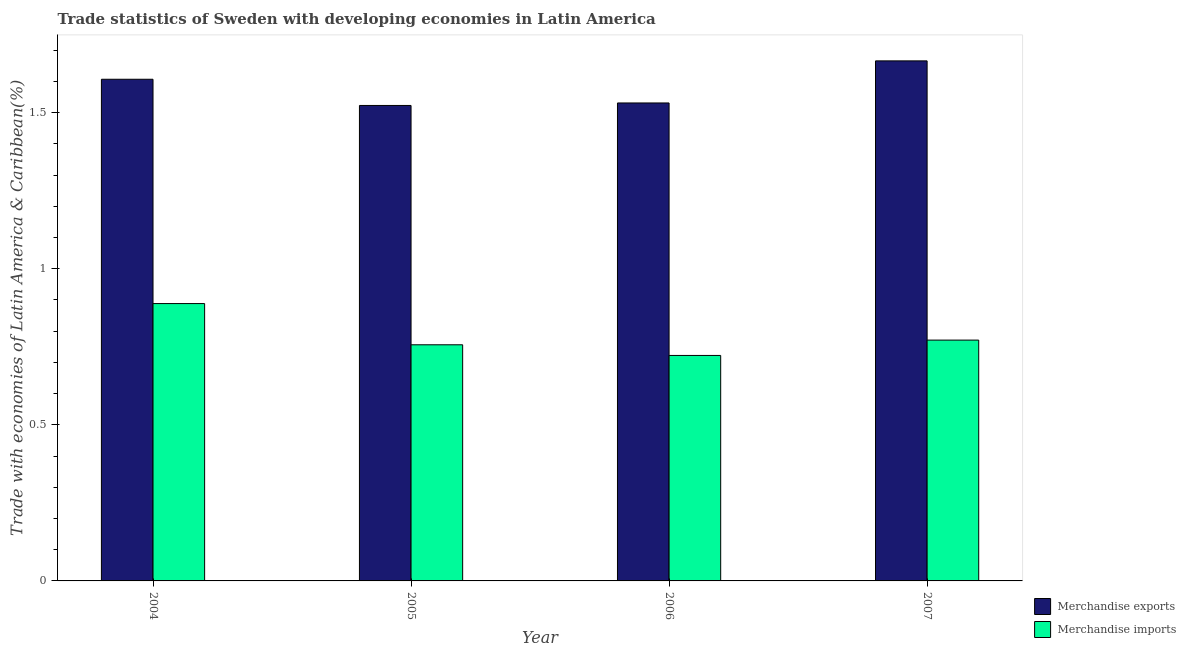How many different coloured bars are there?
Provide a succinct answer. 2. Are the number of bars per tick equal to the number of legend labels?
Make the answer very short. Yes. What is the label of the 2nd group of bars from the left?
Give a very brief answer. 2005. What is the merchandise imports in 2007?
Offer a terse response. 0.77. Across all years, what is the maximum merchandise imports?
Provide a short and direct response. 0.89. Across all years, what is the minimum merchandise exports?
Provide a short and direct response. 1.52. In which year was the merchandise imports maximum?
Give a very brief answer. 2004. What is the total merchandise exports in the graph?
Provide a short and direct response. 6.33. What is the difference between the merchandise imports in 2004 and that in 2006?
Give a very brief answer. 0.17. What is the difference between the merchandise imports in 2005 and the merchandise exports in 2007?
Make the answer very short. -0.02. What is the average merchandise imports per year?
Provide a succinct answer. 0.78. What is the ratio of the merchandise imports in 2006 to that in 2007?
Make the answer very short. 0.94. Is the merchandise imports in 2004 less than that in 2007?
Your answer should be very brief. No. Is the difference between the merchandise imports in 2005 and 2006 greater than the difference between the merchandise exports in 2005 and 2006?
Keep it short and to the point. No. What is the difference between the highest and the second highest merchandise exports?
Keep it short and to the point. 0.06. What is the difference between the highest and the lowest merchandise imports?
Provide a short and direct response. 0.17. Is the sum of the merchandise exports in 2005 and 2006 greater than the maximum merchandise imports across all years?
Your answer should be very brief. Yes. What does the 1st bar from the left in 2004 represents?
Provide a short and direct response. Merchandise exports. What does the 2nd bar from the right in 2007 represents?
Offer a terse response. Merchandise exports. How many bars are there?
Keep it short and to the point. 8. Are all the bars in the graph horizontal?
Make the answer very short. No. How many years are there in the graph?
Your answer should be very brief. 4. What is the title of the graph?
Offer a very short reply. Trade statistics of Sweden with developing economies in Latin America. What is the label or title of the Y-axis?
Your answer should be compact. Trade with economies of Latin America & Caribbean(%). What is the Trade with economies of Latin America & Caribbean(%) in Merchandise exports in 2004?
Offer a very short reply. 1.61. What is the Trade with economies of Latin America & Caribbean(%) of Merchandise imports in 2004?
Offer a terse response. 0.89. What is the Trade with economies of Latin America & Caribbean(%) in Merchandise exports in 2005?
Make the answer very short. 1.52. What is the Trade with economies of Latin America & Caribbean(%) in Merchandise imports in 2005?
Offer a very short reply. 0.76. What is the Trade with economies of Latin America & Caribbean(%) in Merchandise exports in 2006?
Keep it short and to the point. 1.53. What is the Trade with economies of Latin America & Caribbean(%) in Merchandise imports in 2006?
Your answer should be compact. 0.72. What is the Trade with economies of Latin America & Caribbean(%) of Merchandise exports in 2007?
Ensure brevity in your answer.  1.67. What is the Trade with economies of Latin America & Caribbean(%) in Merchandise imports in 2007?
Make the answer very short. 0.77. Across all years, what is the maximum Trade with economies of Latin America & Caribbean(%) in Merchandise exports?
Offer a terse response. 1.67. Across all years, what is the maximum Trade with economies of Latin America & Caribbean(%) in Merchandise imports?
Your response must be concise. 0.89. Across all years, what is the minimum Trade with economies of Latin America & Caribbean(%) in Merchandise exports?
Offer a very short reply. 1.52. Across all years, what is the minimum Trade with economies of Latin America & Caribbean(%) of Merchandise imports?
Your answer should be very brief. 0.72. What is the total Trade with economies of Latin America & Caribbean(%) in Merchandise exports in the graph?
Make the answer very short. 6.33. What is the total Trade with economies of Latin America & Caribbean(%) of Merchandise imports in the graph?
Your answer should be compact. 3.14. What is the difference between the Trade with economies of Latin America & Caribbean(%) in Merchandise exports in 2004 and that in 2005?
Keep it short and to the point. 0.08. What is the difference between the Trade with economies of Latin America & Caribbean(%) in Merchandise imports in 2004 and that in 2005?
Your response must be concise. 0.13. What is the difference between the Trade with economies of Latin America & Caribbean(%) in Merchandise exports in 2004 and that in 2006?
Give a very brief answer. 0.08. What is the difference between the Trade with economies of Latin America & Caribbean(%) of Merchandise imports in 2004 and that in 2006?
Provide a succinct answer. 0.17. What is the difference between the Trade with economies of Latin America & Caribbean(%) in Merchandise exports in 2004 and that in 2007?
Ensure brevity in your answer.  -0.06. What is the difference between the Trade with economies of Latin America & Caribbean(%) of Merchandise imports in 2004 and that in 2007?
Provide a succinct answer. 0.12. What is the difference between the Trade with economies of Latin America & Caribbean(%) of Merchandise exports in 2005 and that in 2006?
Ensure brevity in your answer.  -0.01. What is the difference between the Trade with economies of Latin America & Caribbean(%) of Merchandise imports in 2005 and that in 2006?
Make the answer very short. 0.03. What is the difference between the Trade with economies of Latin America & Caribbean(%) in Merchandise exports in 2005 and that in 2007?
Ensure brevity in your answer.  -0.14. What is the difference between the Trade with economies of Latin America & Caribbean(%) of Merchandise imports in 2005 and that in 2007?
Offer a very short reply. -0.01. What is the difference between the Trade with economies of Latin America & Caribbean(%) of Merchandise exports in 2006 and that in 2007?
Give a very brief answer. -0.13. What is the difference between the Trade with economies of Latin America & Caribbean(%) of Merchandise imports in 2006 and that in 2007?
Keep it short and to the point. -0.05. What is the difference between the Trade with economies of Latin America & Caribbean(%) of Merchandise exports in 2004 and the Trade with economies of Latin America & Caribbean(%) of Merchandise imports in 2005?
Provide a short and direct response. 0.85. What is the difference between the Trade with economies of Latin America & Caribbean(%) in Merchandise exports in 2004 and the Trade with economies of Latin America & Caribbean(%) in Merchandise imports in 2006?
Provide a succinct answer. 0.88. What is the difference between the Trade with economies of Latin America & Caribbean(%) of Merchandise exports in 2004 and the Trade with economies of Latin America & Caribbean(%) of Merchandise imports in 2007?
Ensure brevity in your answer.  0.84. What is the difference between the Trade with economies of Latin America & Caribbean(%) in Merchandise exports in 2005 and the Trade with economies of Latin America & Caribbean(%) in Merchandise imports in 2006?
Offer a terse response. 0.8. What is the difference between the Trade with economies of Latin America & Caribbean(%) in Merchandise exports in 2005 and the Trade with economies of Latin America & Caribbean(%) in Merchandise imports in 2007?
Provide a short and direct response. 0.75. What is the difference between the Trade with economies of Latin America & Caribbean(%) in Merchandise exports in 2006 and the Trade with economies of Latin America & Caribbean(%) in Merchandise imports in 2007?
Offer a terse response. 0.76. What is the average Trade with economies of Latin America & Caribbean(%) of Merchandise exports per year?
Offer a terse response. 1.58. What is the average Trade with economies of Latin America & Caribbean(%) in Merchandise imports per year?
Your answer should be compact. 0.78. In the year 2004, what is the difference between the Trade with economies of Latin America & Caribbean(%) in Merchandise exports and Trade with economies of Latin America & Caribbean(%) in Merchandise imports?
Offer a very short reply. 0.72. In the year 2005, what is the difference between the Trade with economies of Latin America & Caribbean(%) in Merchandise exports and Trade with economies of Latin America & Caribbean(%) in Merchandise imports?
Make the answer very short. 0.77. In the year 2006, what is the difference between the Trade with economies of Latin America & Caribbean(%) in Merchandise exports and Trade with economies of Latin America & Caribbean(%) in Merchandise imports?
Keep it short and to the point. 0.81. In the year 2007, what is the difference between the Trade with economies of Latin America & Caribbean(%) of Merchandise exports and Trade with economies of Latin America & Caribbean(%) of Merchandise imports?
Give a very brief answer. 0.89. What is the ratio of the Trade with economies of Latin America & Caribbean(%) in Merchandise exports in 2004 to that in 2005?
Keep it short and to the point. 1.06. What is the ratio of the Trade with economies of Latin America & Caribbean(%) in Merchandise imports in 2004 to that in 2005?
Ensure brevity in your answer.  1.17. What is the ratio of the Trade with economies of Latin America & Caribbean(%) of Merchandise exports in 2004 to that in 2006?
Ensure brevity in your answer.  1.05. What is the ratio of the Trade with economies of Latin America & Caribbean(%) in Merchandise imports in 2004 to that in 2006?
Your answer should be very brief. 1.23. What is the ratio of the Trade with economies of Latin America & Caribbean(%) in Merchandise exports in 2004 to that in 2007?
Keep it short and to the point. 0.96. What is the ratio of the Trade with economies of Latin America & Caribbean(%) of Merchandise imports in 2004 to that in 2007?
Your response must be concise. 1.15. What is the ratio of the Trade with economies of Latin America & Caribbean(%) of Merchandise imports in 2005 to that in 2006?
Offer a very short reply. 1.05. What is the ratio of the Trade with economies of Latin America & Caribbean(%) in Merchandise exports in 2005 to that in 2007?
Make the answer very short. 0.91. What is the ratio of the Trade with economies of Latin America & Caribbean(%) of Merchandise imports in 2005 to that in 2007?
Give a very brief answer. 0.98. What is the ratio of the Trade with economies of Latin America & Caribbean(%) of Merchandise exports in 2006 to that in 2007?
Give a very brief answer. 0.92. What is the ratio of the Trade with economies of Latin America & Caribbean(%) in Merchandise imports in 2006 to that in 2007?
Your response must be concise. 0.94. What is the difference between the highest and the second highest Trade with economies of Latin America & Caribbean(%) of Merchandise exports?
Keep it short and to the point. 0.06. What is the difference between the highest and the second highest Trade with economies of Latin America & Caribbean(%) of Merchandise imports?
Make the answer very short. 0.12. What is the difference between the highest and the lowest Trade with economies of Latin America & Caribbean(%) in Merchandise exports?
Offer a terse response. 0.14. What is the difference between the highest and the lowest Trade with economies of Latin America & Caribbean(%) of Merchandise imports?
Provide a succinct answer. 0.17. 